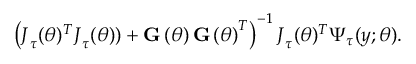<formula> <loc_0><loc_0><loc_500><loc_500>\left ( J _ { \tau } ( \theta ) ^ { T } J _ { \tau } ( \theta ) ) + G \left ( \theta \right ) G \left ( \theta \right ) ^ { T } \right ) ^ { - 1 } J _ { \tau } ( \theta ) ^ { T } \Psi _ { \tau } ( y ; \theta ) .</formula> 